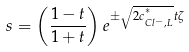<formula> <loc_0><loc_0><loc_500><loc_500>s = \left ( \frac { 1 - t } { 1 + t } \right ) e ^ { \pm \sqrt { 2 c ^ { ^ { * } } _ { C l ^ { - } , L } } t \zeta }</formula> 